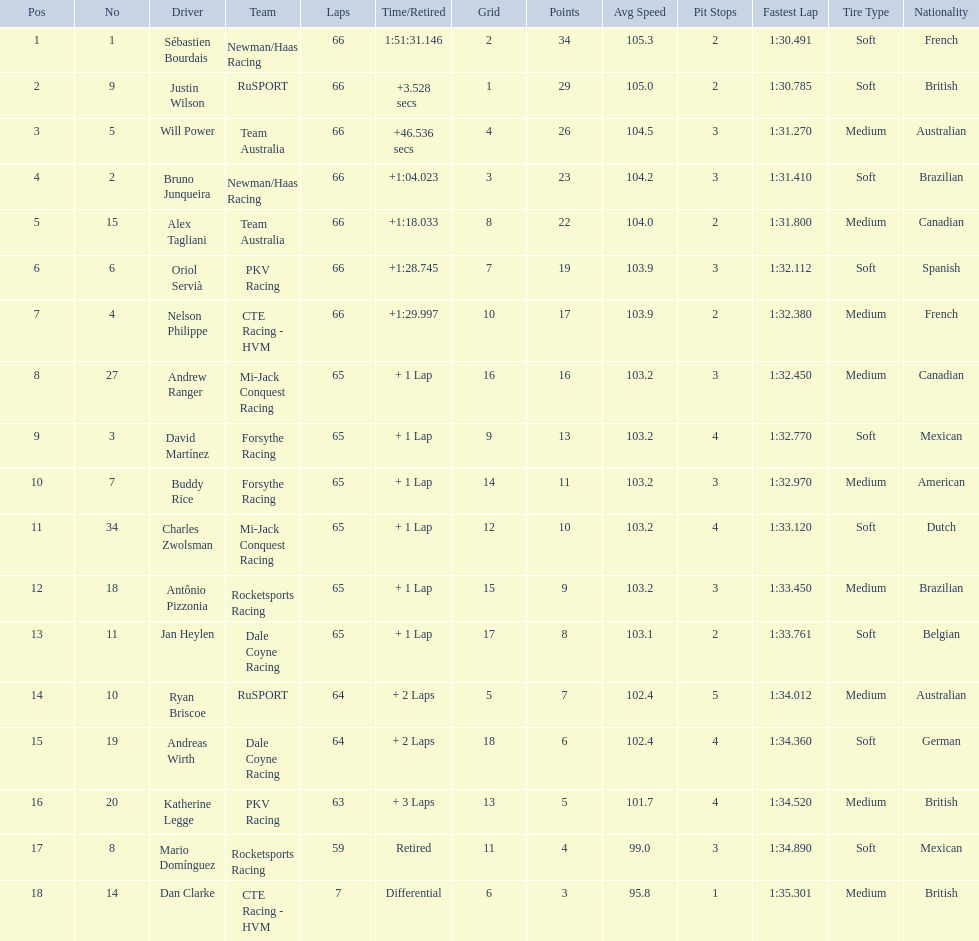At the 2006 gran premio telmex, how many drivers completed less than 60 laps? 2. 